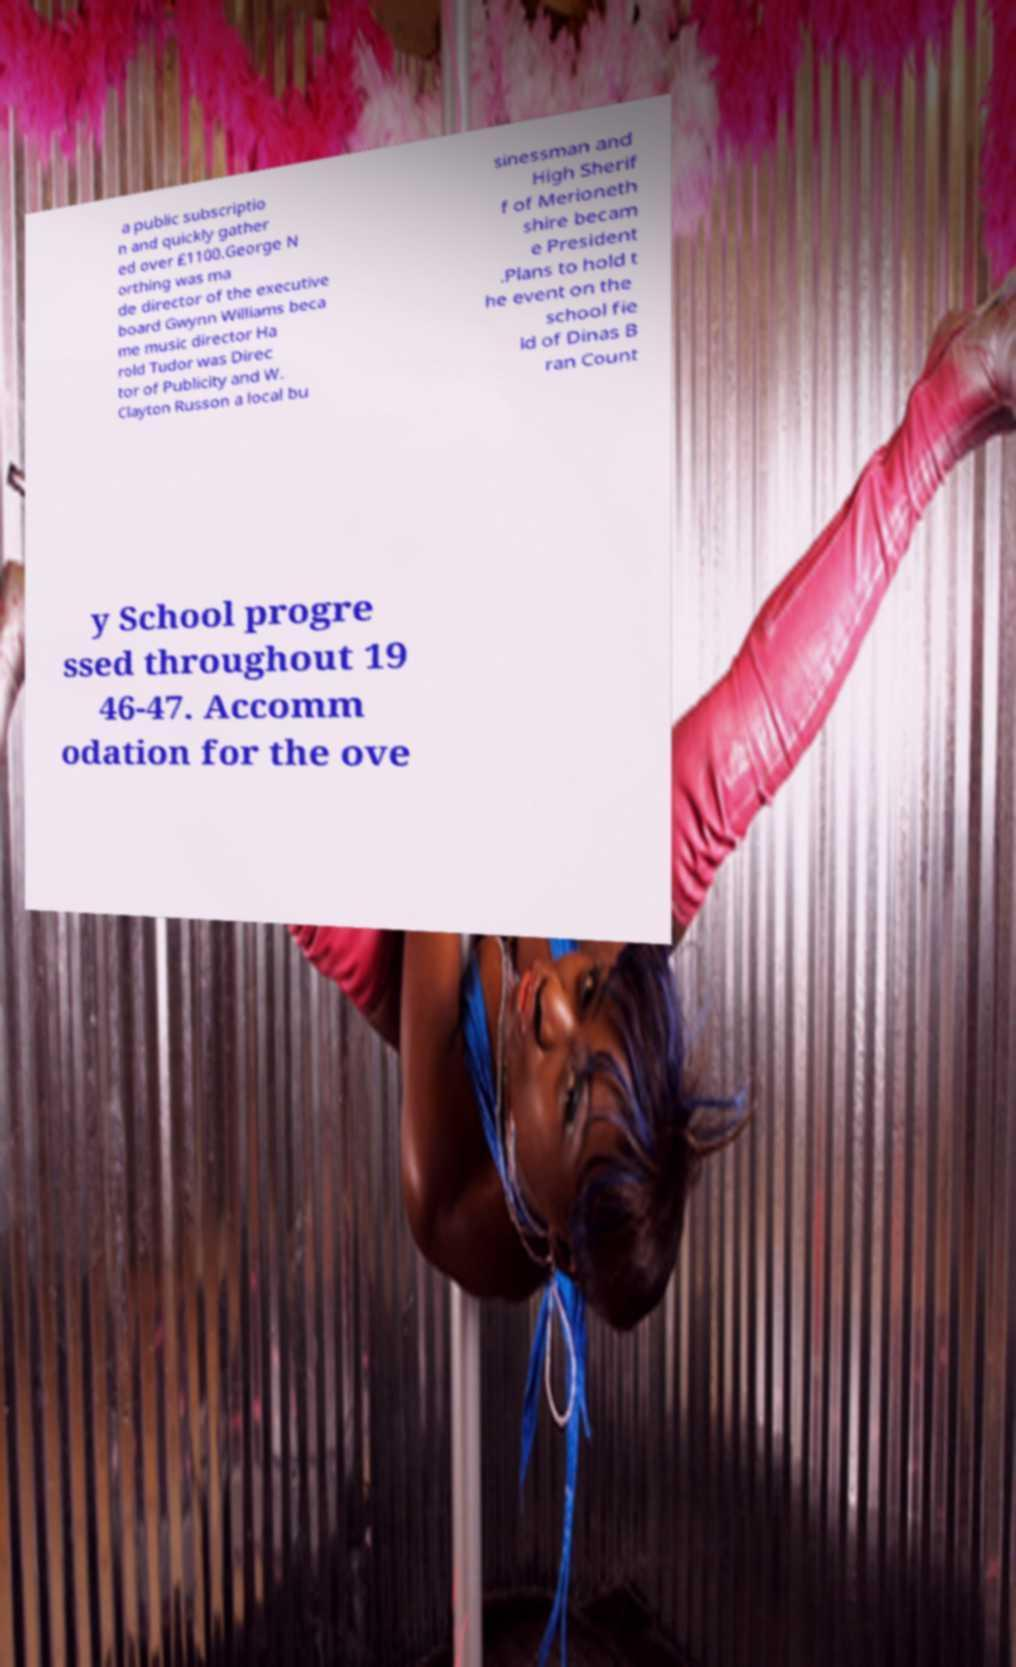For documentation purposes, I need the text within this image transcribed. Could you provide that? a public subscriptio n and quickly gather ed over £1100.George N orthing was ma de director of the executive board Gwynn Williams beca me music director Ha rold Tudor was Direc tor of Publicity and W. Clayton Russon a local bu sinessman and High Sherif f of Merioneth shire becam e President .Plans to hold t he event on the school fie ld of Dinas B ran Count y School progre ssed throughout 19 46-47. Accomm odation for the ove 